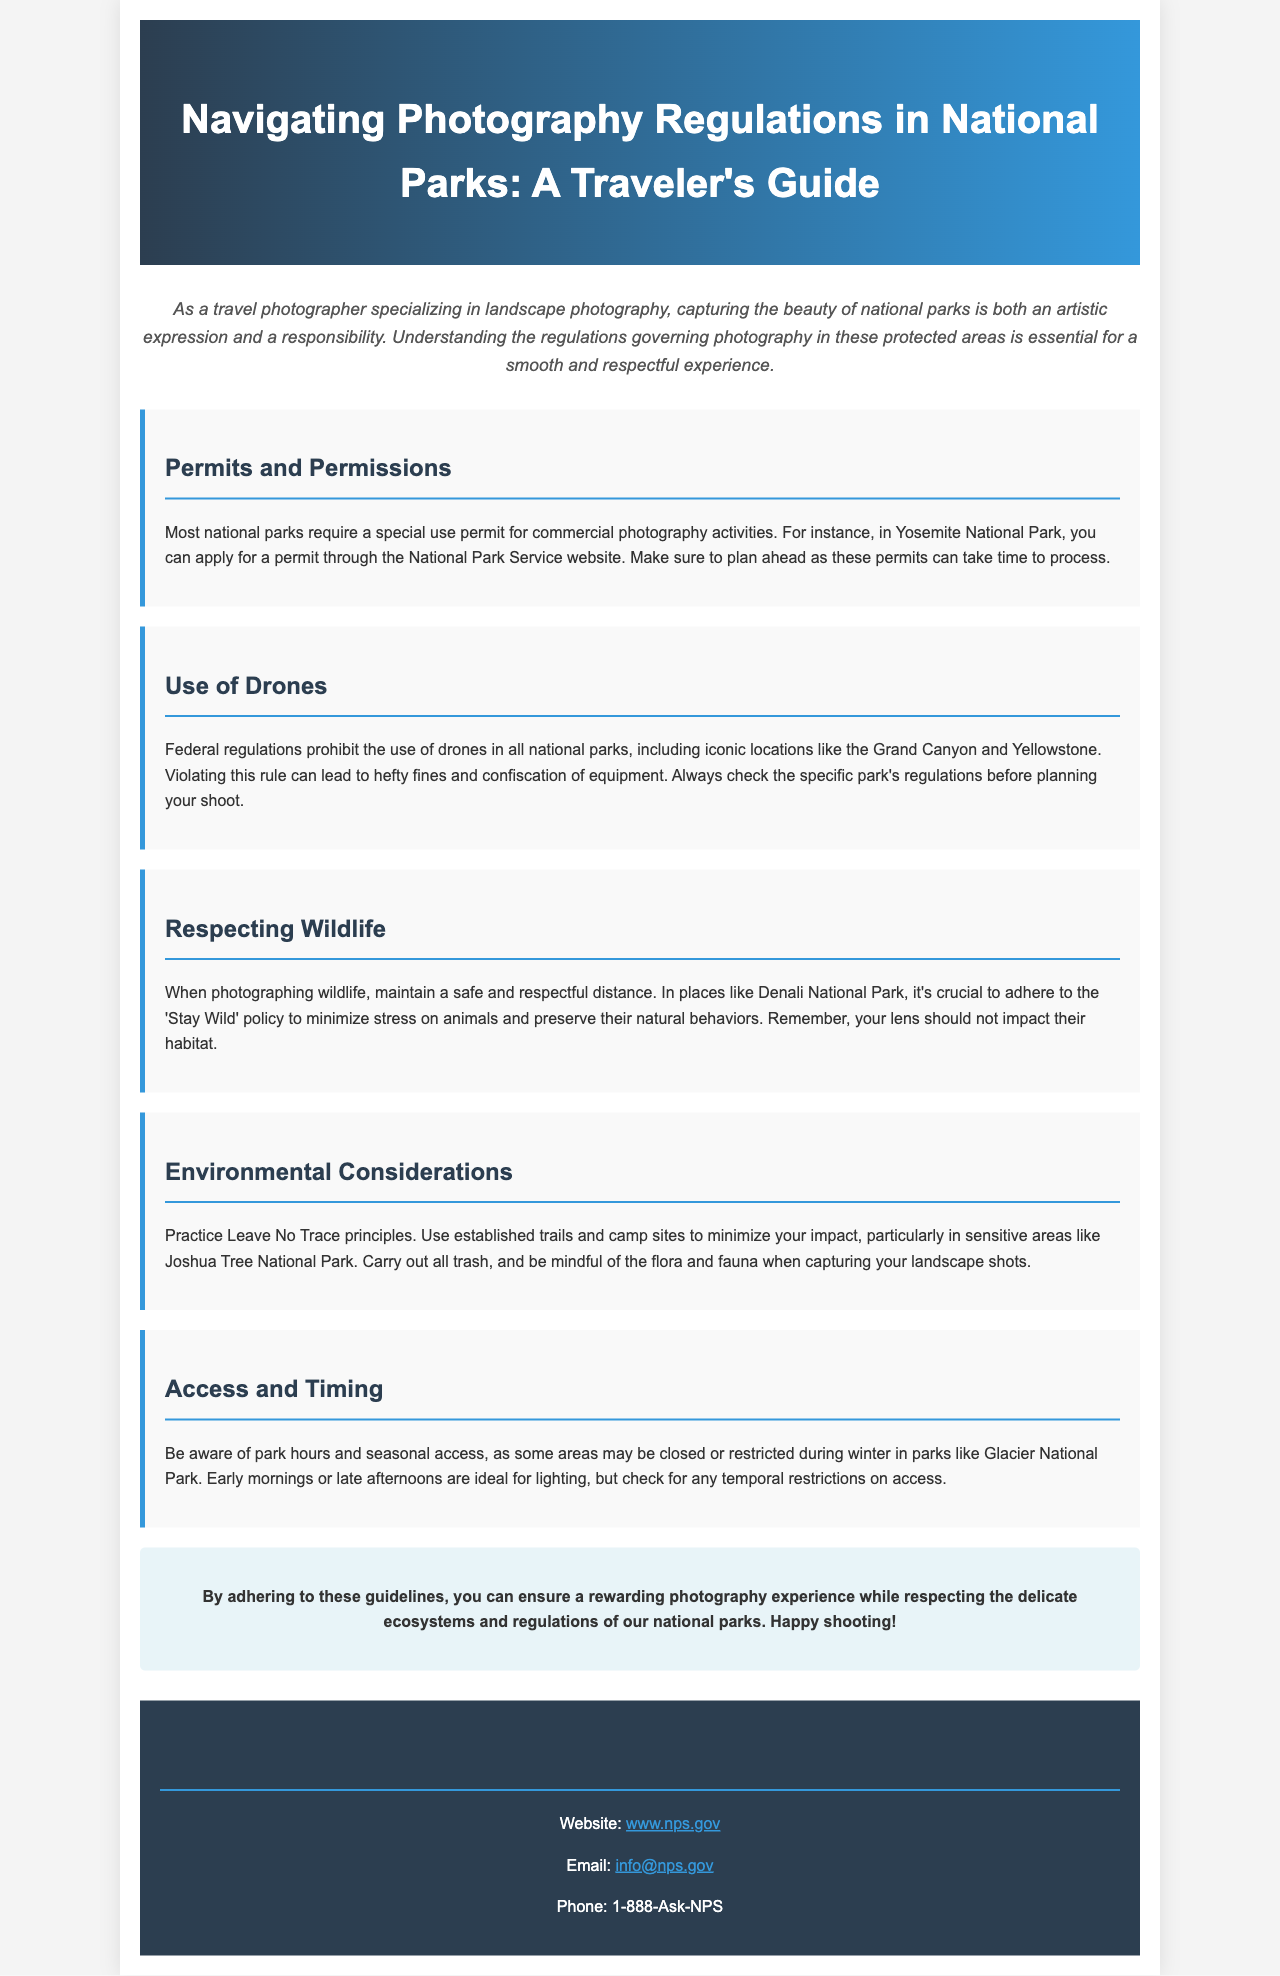What is the title of the brochure? The title is found in the header section of the document, summarizing its purpose.
Answer: Navigating Photography Regulations in National Parks: A Traveler's Guide What is required for commercial photography in national parks? This information is stated in the "Permits and Permissions" section, outlining the need for a specific document.
Answer: A special use permit Are drones allowed in national parks? The "Use of Drones" section clearly mentions regulations regarding drone usage in these areas.
Answer: No What should photographers maintain when photographing wildlife? The "Respecting Wildlife" section emphasizes a key ethical guideline for wildlife photography.
Answer: A safe and respectful distance Which national park requires adherence to the 'Stay Wild' policy? The "Respecting Wildlife" section mentions this specific park and its relevant policy.
Answer: Denali National Park What principle should photographers practice to minimize impact? The "Environmental Considerations" section mentions this guiding principle for responsible behavior.
Answer: Leave No Trace What is suggested as the ideal time for photography to capture good lighting? The "Access and Timing" section provides advice regarding optimal shooting times during the day.
Answer: Early mornings or late afternoons What is the contact phone number provided in the brochure? The contact section includes relevant information for reaching out to the national park service.
Answer: 1-888-Ask-NPS 